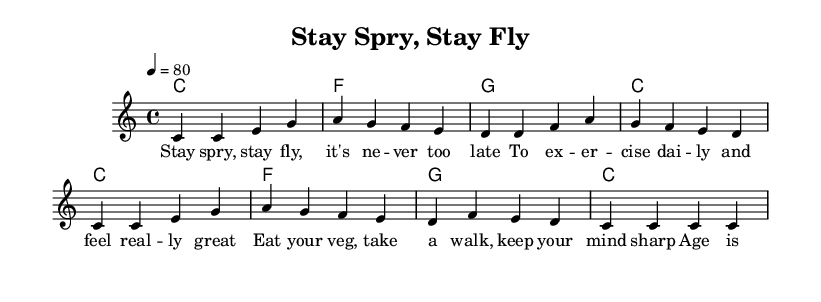What is the key signature of this music? The key signature is C major, which has no sharps or flats.
Answer: C major What is the time signature of this music? The time signature is 4/4, which means there are four beats in each measure.
Answer: 4/4 What is the tempo marking of this music? The tempo is set at 80 beats per minute, indicated by '4 = 80'.
Answer: 80 How many measures are in the melody? The melody consists of 8 measures, as counted from the music notation.
Answer: 8 What is the primary theme of the lyrics? The primary theme promotes health and wellness, emphasizing exercise and healthy eating for seniors.
Answer: Health and wellness In which measure does the phrase "Stay spry, stay fly" appear? This phrase appears at the beginning of the first measure, forming the opening of the lyrics.
Answer: Measure 1 What musical genre is represented in this sheet music? The musical genre is Rap, characterized by its rhythmic vocal style and lyrical content.
Answer: Rap 